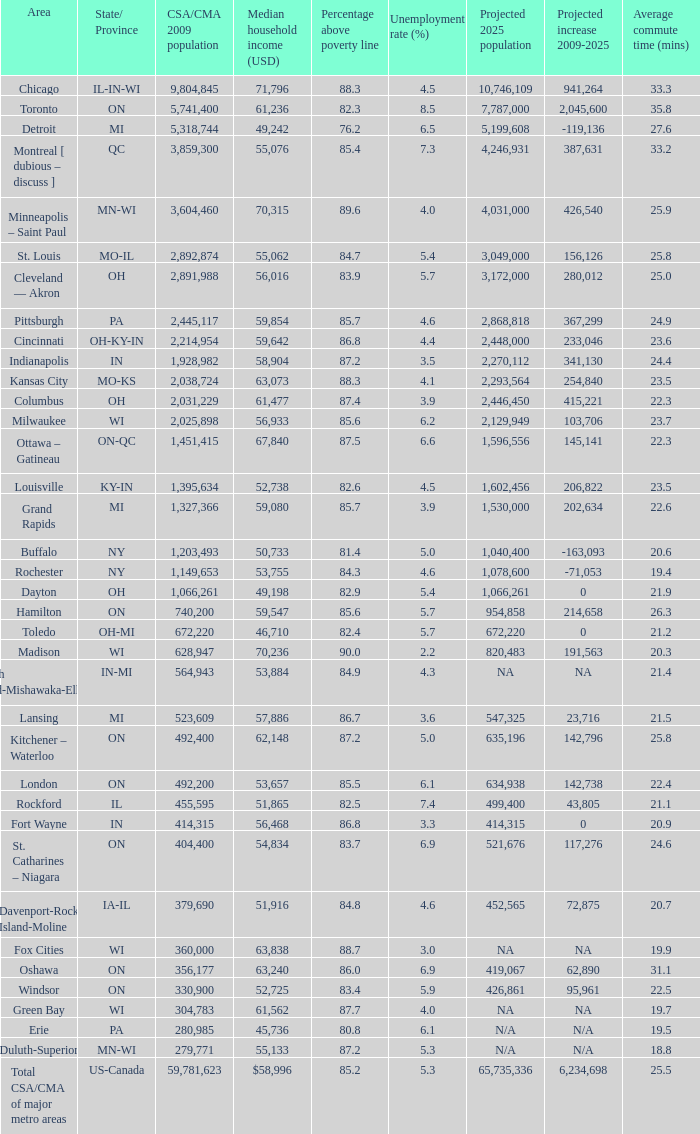What's the projected population of IN-MI? NA. 